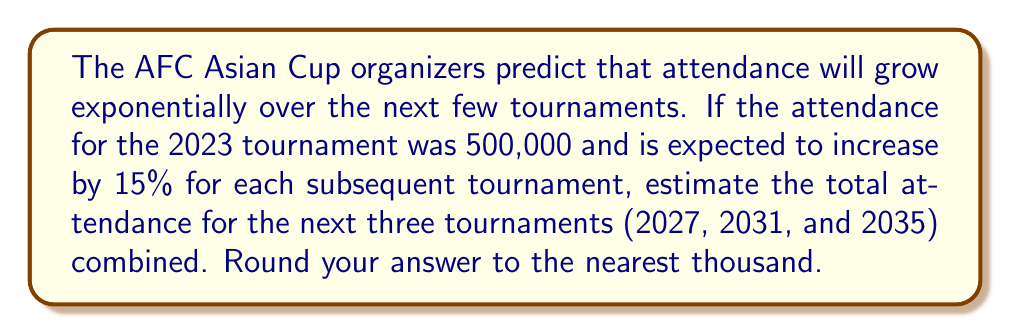What is the answer to this math problem? Let's approach this step-by-step:

1) We're dealing with exponential growth, so we'll use the formula:
   $A(n) = A_0(1 + r)^n$
   where $A(n)$ is the attendance after $n$ tournaments, $A_0$ is the initial attendance, and $r$ is the growth rate.

2) Given:
   $A_0 = 500,000$
   $r = 15\% = 0.15$

3) Let's calculate the attendance for each tournament:

   2027 (1 tournament later): $A(1) = 500,000(1 + 0.15)^1 = 500,000(1.15) = 575,000$

   2031 (2 tournaments later): $A(2) = 500,000(1 + 0.15)^2 = 500,000(1.15)^2 = 661,250$

   2035 (3 tournaments later): $A(3) = 500,000(1 + 0.15)^3 = 500,000(1.15)^3 = 760,437.5$

4) To get the total attendance, we sum these values:
   $575,000 + 661,250 + 760,437.5 = 1,996,687.5$

5) Rounding to the nearest thousand:
   $1,996,687.5 \approx 1,997,000$
Answer: 1,997,000 